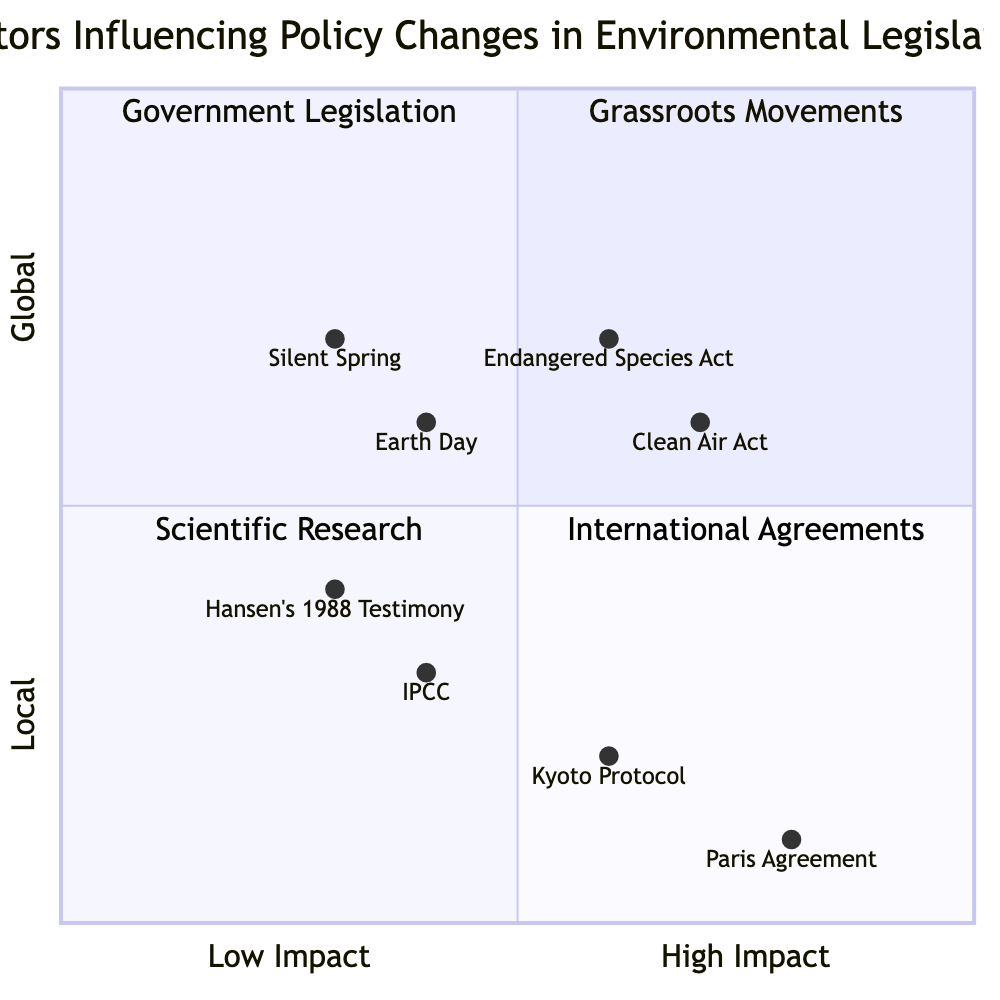What are the key elements in the "Top Left" quadrant? The "Top Left" quadrant is titled "Grassroots Movements" and contains two elements: "Silent Spring" and "Earth Day".
Answer: Silent Spring, Earth Day Which environmental legislation is located in the "Top Right" quadrant? The "Top Right" quadrant is titled "Government Legislation" and features two key pieces of legislation: "Clean Air Act" and "Endangered Species Act".
Answer: Clean Air Act, Endangered Species Act What is the y-axis label of this diagram? The y-axis of the diagram is labeled "Local --> Global".
Answer: Local --> Global How many elements are in the "Bottom Left" quadrant? The "Bottom Left" quadrant is titled "Scientific Research" and contains two elements: "Intergovernmental Panel on Climate Change (IPCC)" and "Hansen’s 1988 Testimony", thus there are two elements.
Answer: 2 Which factor has the highest impact score in the "International Agreements" quadrant? In the "Bottom Right" quadrant "International Agreements", the "Paris Agreement" has the highest impact score of 0.8.
Answer: Paris Agreement What quadrant contains the element "Silent Spring"? "Silent Spring" is located in the "Top Left" quadrant, which focuses on grassroots movements.
Answer: Top Left What is the relationship between the "Hansen’s 1988 Testimony" and the "Intergovernmental Panel on Climate Change (IPCC)" elements? Both "Hansen’s 1988 Testimony" and "Intergovernmental Panel on Climate Change (IPCC)" are located in the "Bottom Left" quadrant, indicating their connection to scientific research.
Answer: Scientific Research Which legislation was enacted earlier, "Clean Air Act" or "Endangered Species Act"? The "Clean Air Act" was enacted in 1970, while the "Endangered Species Act" followed in 1973; thus, the "Clean Air Act" was enacted earlier.
Answer: Clean Air Act In which quadrant would you find elements with a high impact but local influence? Elements with a high impact but local influence are found in the "Top Right" quadrant, which focuses on Government Legislation.
Answer: Top Right 